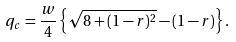<formula> <loc_0><loc_0><loc_500><loc_500>q _ { c } = \frac { w } { 4 } \left \{ \sqrt { 8 + ( 1 - r ) ^ { 2 } } - ( 1 - r ) \right \} .</formula> 